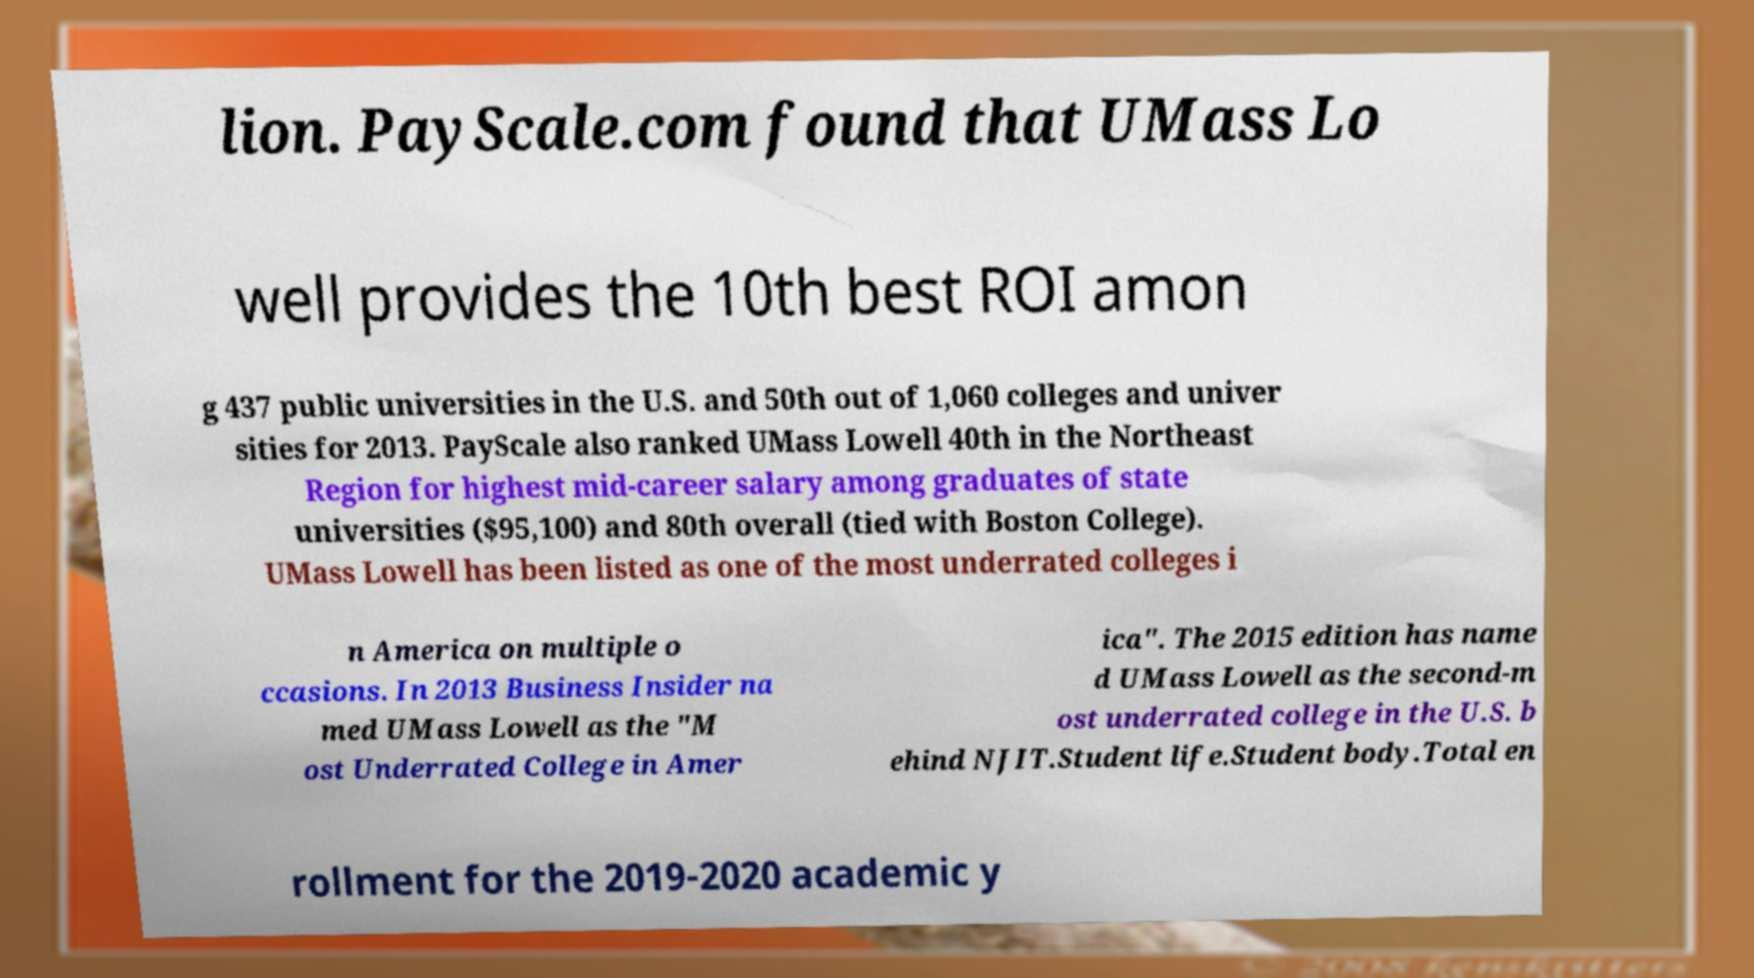Please read and relay the text visible in this image. What does it say? lion. PayScale.com found that UMass Lo well provides the 10th best ROI amon g 437 public universities in the U.S. and 50th out of 1,060 colleges and univer sities for 2013. PayScale also ranked UMass Lowell 40th in the Northeast Region for highest mid-career salary among graduates of state universities ($95,100) and 80th overall (tied with Boston College). UMass Lowell has been listed as one of the most underrated colleges i n America on multiple o ccasions. In 2013 Business Insider na med UMass Lowell as the "M ost Underrated College in Amer ica". The 2015 edition has name d UMass Lowell as the second-m ost underrated college in the U.S. b ehind NJIT.Student life.Student body.Total en rollment for the 2019-2020 academic y 